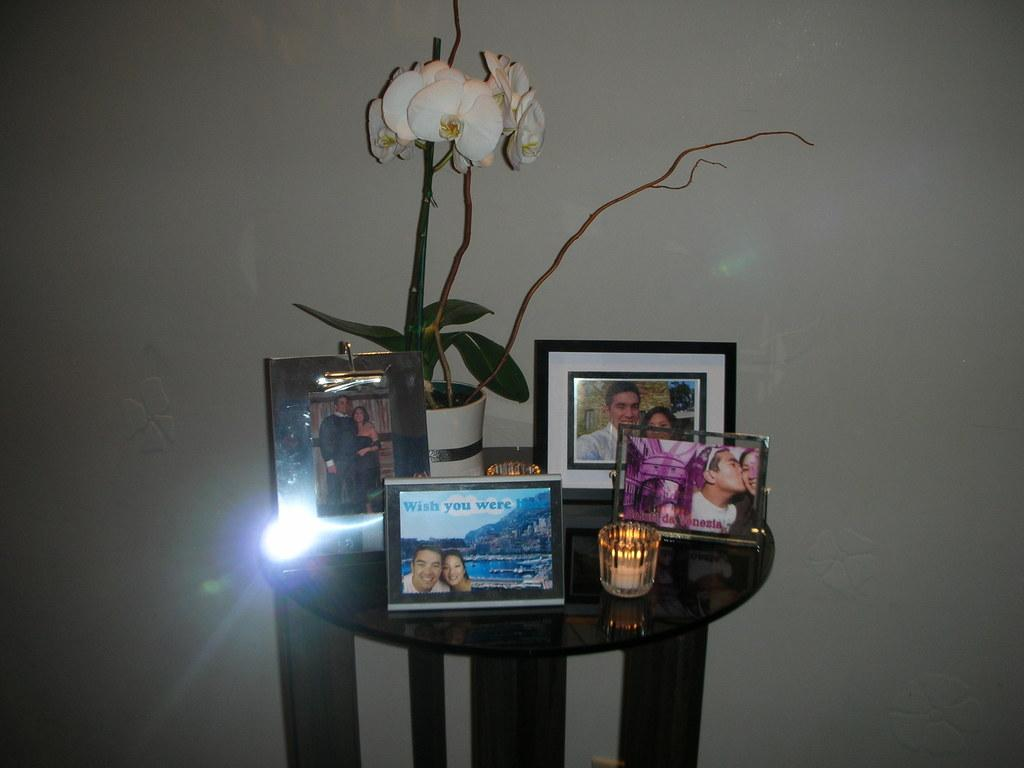<image>
Summarize the visual content of the image. A small table filled with photo frames and a photo with a couple that says Wish you were here 